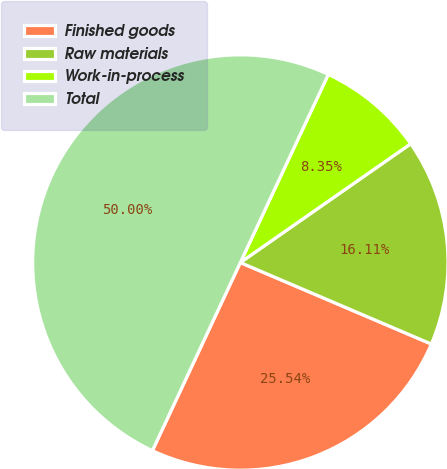<chart> <loc_0><loc_0><loc_500><loc_500><pie_chart><fcel>Finished goods<fcel>Raw materials<fcel>Work-in-process<fcel>Total<nl><fcel>25.54%<fcel>16.11%<fcel>8.35%<fcel>50.0%<nl></chart> 